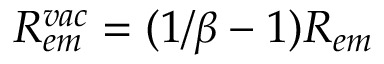Convert formula to latex. <formula><loc_0><loc_0><loc_500><loc_500>R _ { e m } ^ { v a c } = ( 1 / \beta - 1 ) R _ { e m }</formula> 